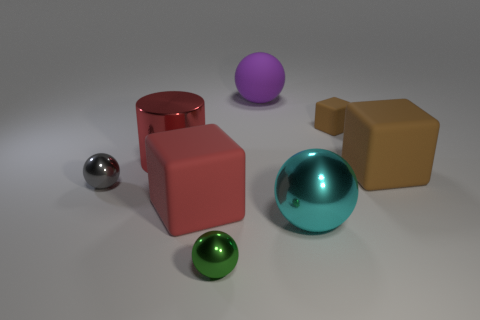Are there any objects of the same color as the cylinder?
Your answer should be compact. Yes. There is a tiny shiny ball that is on the left side of the red shiny cylinder; how many big matte blocks are behind it?
Provide a short and direct response. 1. How many tiny blue spheres have the same material as the small green thing?
Keep it short and to the point. 0. What number of large objects are either blue metal objects or cyan balls?
Offer a terse response. 1. What is the shape of the small object that is both to the right of the big red matte thing and behind the cyan ball?
Provide a short and direct response. Cube. Does the large brown object have the same material as the large cylinder?
Keep it short and to the point. No. What is the color of the other metallic ball that is the same size as the purple sphere?
Offer a terse response. Cyan. What color is the rubber object that is both in front of the tiny brown matte block and left of the tiny matte object?
Offer a terse response. Red. What is the size of the matte thing that is the same color as the big cylinder?
Your answer should be very brief. Large. There is a red object that is to the left of the matte object that is in front of the large object that is to the right of the big cyan thing; what size is it?
Provide a short and direct response. Large. 